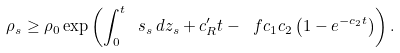Convert formula to latex. <formula><loc_0><loc_0><loc_500><loc_500>\rho _ { s } \geq \rho _ { 0 } \exp \left ( \int _ { 0 } ^ { t } \ s _ { s } \, d z _ { s } + c _ { R } ^ { \prime } t - \ f { c _ { 1 } } { c _ { 2 } } \left ( 1 - e ^ { - c _ { 2 } t } \right ) \right ) .</formula> 